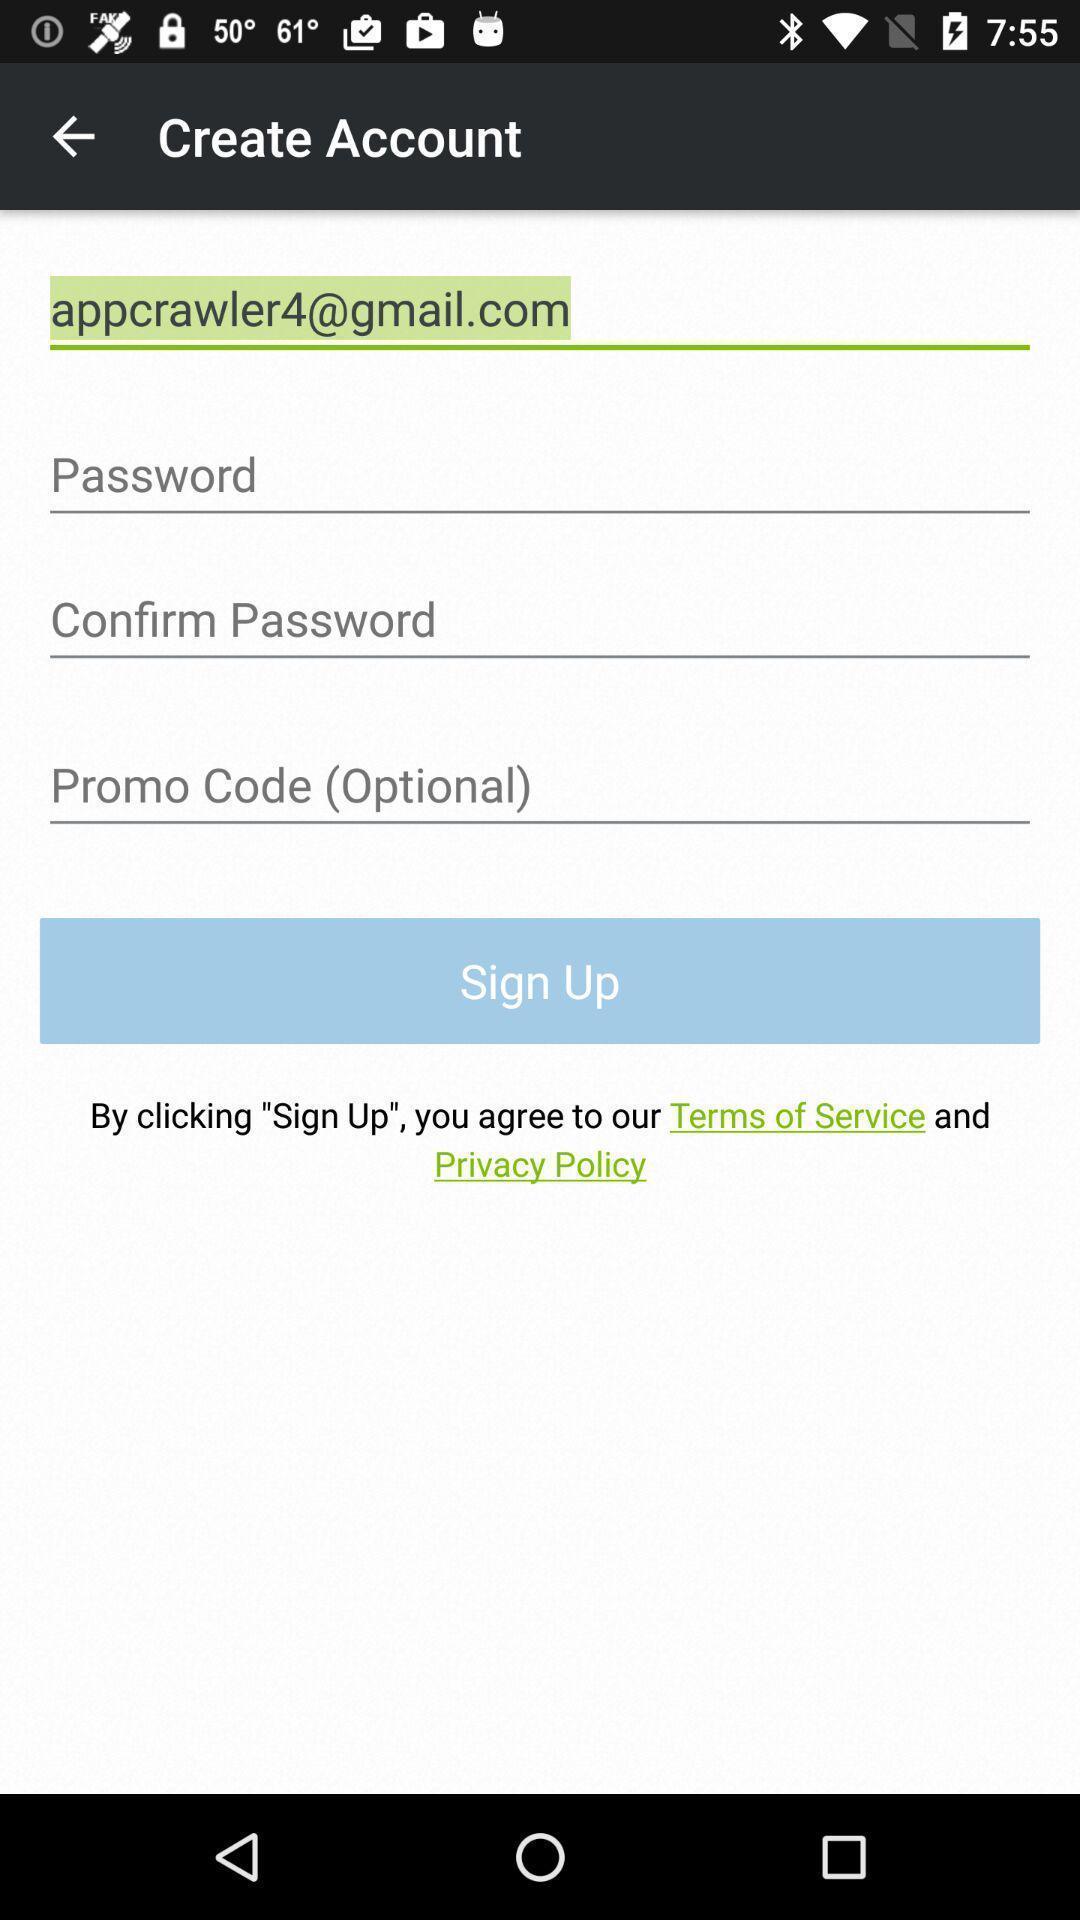Summarize the main components in this picture. Sign up page to create an account. 